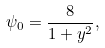<formula> <loc_0><loc_0><loc_500><loc_500>\psi _ { 0 } = \frac { 8 } { 1 + y ^ { 2 } } ,</formula> 